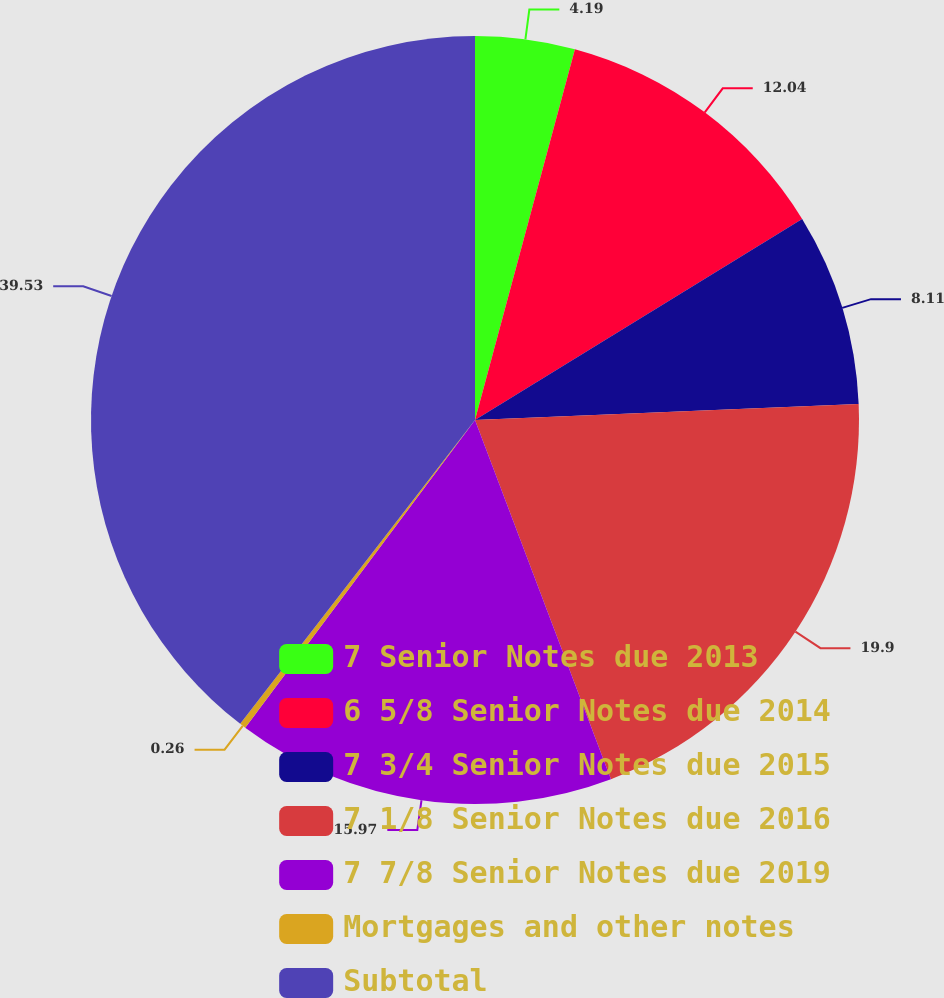Convert chart to OTSL. <chart><loc_0><loc_0><loc_500><loc_500><pie_chart><fcel>7 Senior Notes due 2013<fcel>6 5/8 Senior Notes due 2014<fcel>7 3/4 Senior Notes due 2015<fcel>7 1/8 Senior Notes due 2016<fcel>7 7/8 Senior Notes due 2019<fcel>Mortgages and other notes<fcel>Subtotal<nl><fcel>4.19%<fcel>12.04%<fcel>8.11%<fcel>19.9%<fcel>15.97%<fcel>0.26%<fcel>39.53%<nl></chart> 